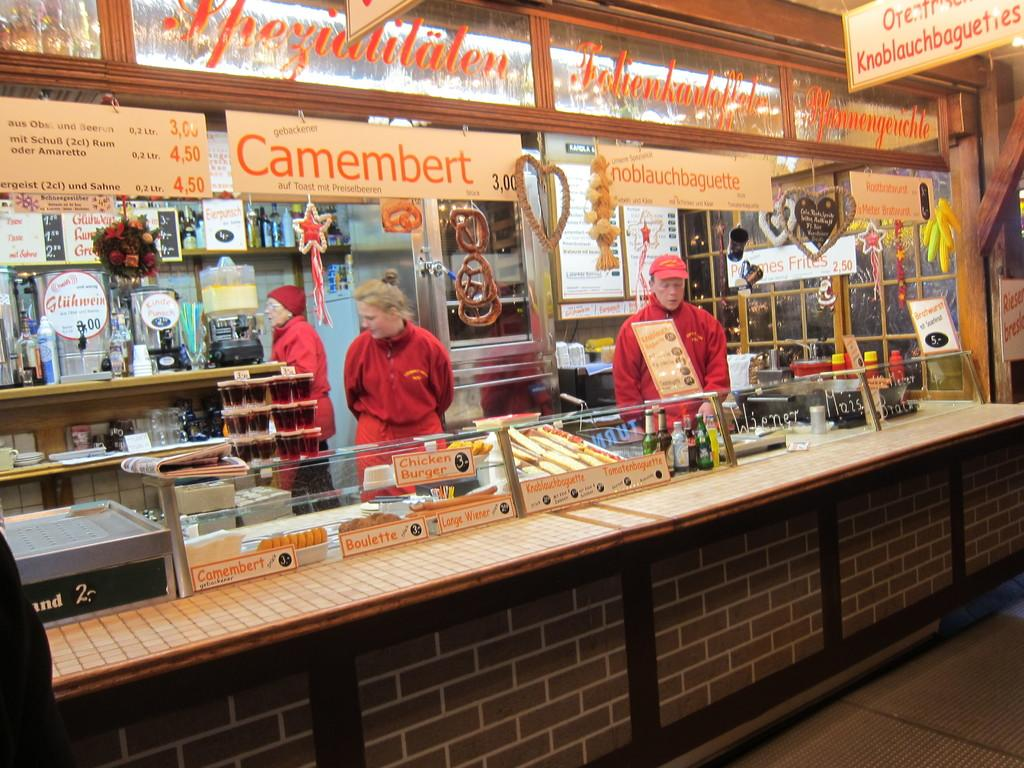<image>
Relay a brief, clear account of the picture shown. People working in a stand selling food with a sign "Camembert" on top. 